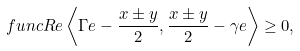<formula> <loc_0><loc_0><loc_500><loc_500>\ f u n c { R e } \left \langle \Gamma e - \frac { x \pm y } { 2 } , \frac { x \pm y } { 2 } - \gamma e \right \rangle \geq 0 ,</formula> 